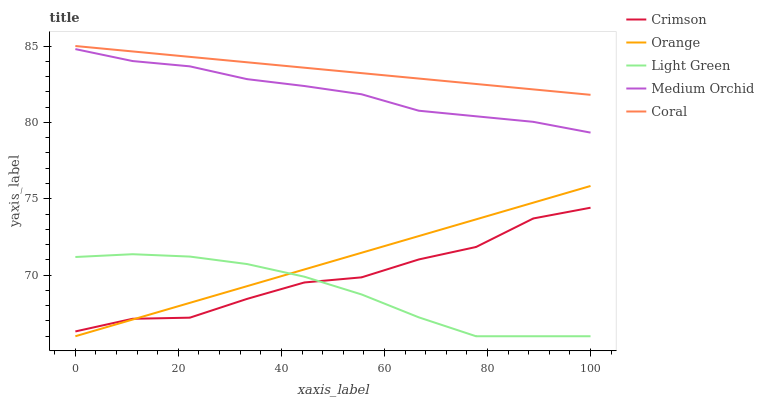Does Light Green have the minimum area under the curve?
Answer yes or no. Yes. Does Coral have the maximum area under the curve?
Answer yes or no. Yes. Does Orange have the minimum area under the curve?
Answer yes or no. No. Does Orange have the maximum area under the curve?
Answer yes or no. No. Is Coral the smoothest?
Answer yes or no. Yes. Is Crimson the roughest?
Answer yes or no. Yes. Is Orange the smoothest?
Answer yes or no. No. Is Orange the roughest?
Answer yes or no. No. Does Orange have the lowest value?
Answer yes or no. Yes. Does Coral have the lowest value?
Answer yes or no. No. Does Coral have the highest value?
Answer yes or no. Yes. Does Orange have the highest value?
Answer yes or no. No. Is Orange less than Medium Orchid?
Answer yes or no. Yes. Is Medium Orchid greater than Light Green?
Answer yes or no. Yes. Does Orange intersect Light Green?
Answer yes or no. Yes. Is Orange less than Light Green?
Answer yes or no. No. Is Orange greater than Light Green?
Answer yes or no. No. Does Orange intersect Medium Orchid?
Answer yes or no. No. 